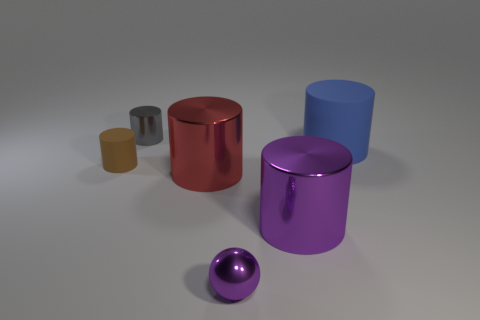Subtract 1 cylinders. How many cylinders are left? 4 Subtract all purple cylinders. How many cylinders are left? 4 Subtract all big purple metallic cylinders. How many cylinders are left? 4 Subtract all cyan cylinders. Subtract all green blocks. How many cylinders are left? 5 Add 3 purple shiny spheres. How many objects exist? 9 Subtract all cylinders. How many objects are left? 1 Subtract all tiny brown shiny cylinders. Subtract all red shiny cylinders. How many objects are left? 5 Add 4 large things. How many large things are left? 7 Add 2 small brown metal blocks. How many small brown metal blocks exist? 2 Subtract 0 yellow balls. How many objects are left? 6 